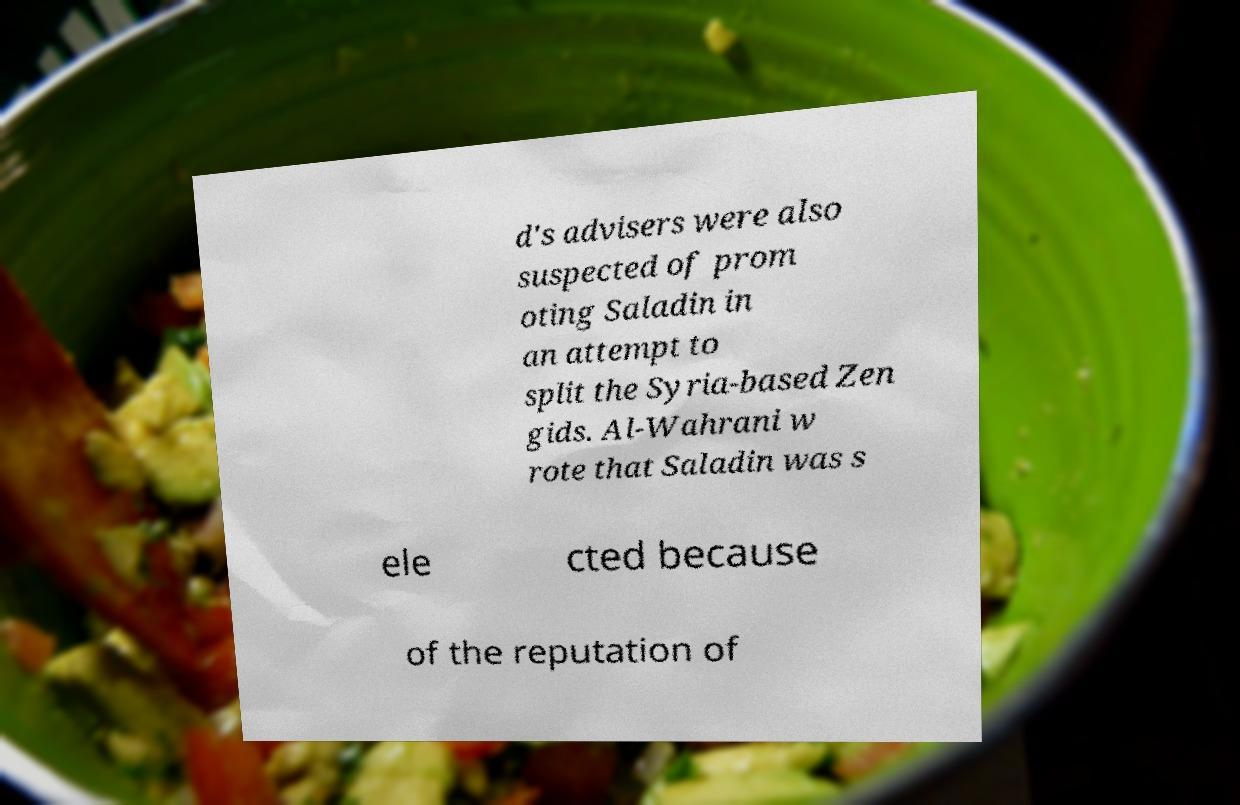Could you assist in decoding the text presented in this image and type it out clearly? d's advisers were also suspected of prom oting Saladin in an attempt to split the Syria-based Zen gids. Al-Wahrani w rote that Saladin was s ele cted because of the reputation of 